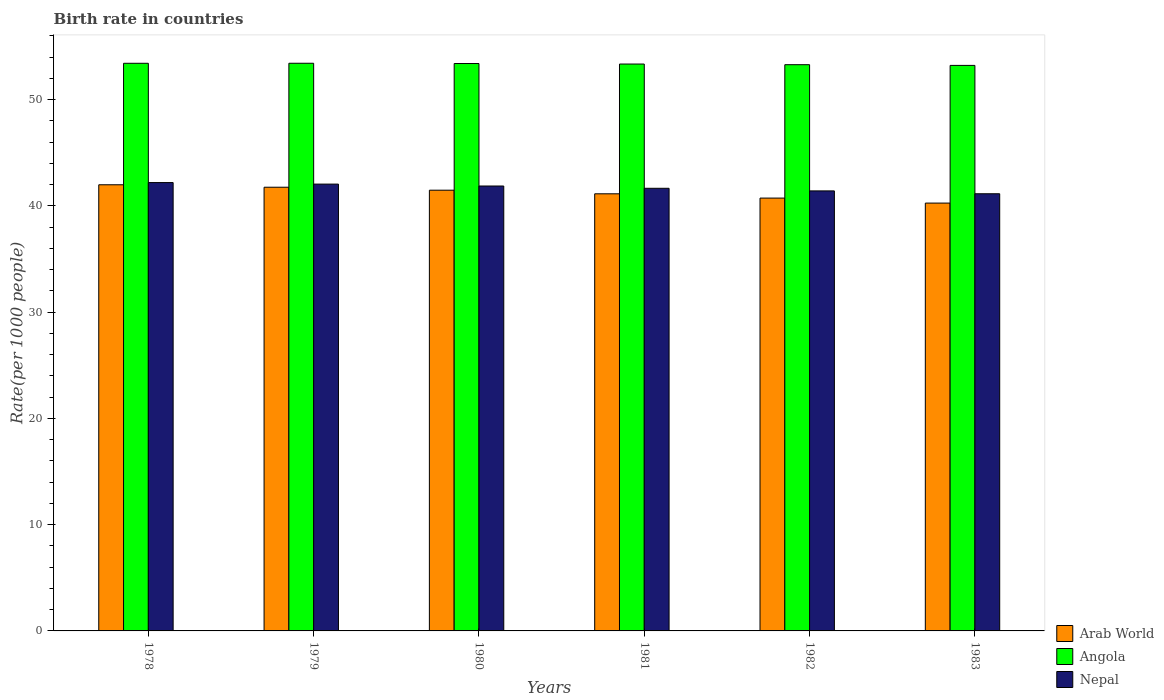Are the number of bars per tick equal to the number of legend labels?
Offer a terse response. Yes. Are the number of bars on each tick of the X-axis equal?
Your answer should be compact. Yes. How many bars are there on the 4th tick from the right?
Give a very brief answer. 3. What is the label of the 1st group of bars from the left?
Ensure brevity in your answer.  1978. In how many cases, is the number of bars for a given year not equal to the number of legend labels?
Make the answer very short. 0. What is the birth rate in Arab World in 1978?
Provide a succinct answer. 41.99. Across all years, what is the maximum birth rate in Nepal?
Give a very brief answer. 42.2. Across all years, what is the minimum birth rate in Nepal?
Provide a succinct answer. 41.14. In which year was the birth rate in Angola maximum?
Your response must be concise. 1979. In which year was the birth rate in Arab World minimum?
Provide a short and direct response. 1983. What is the total birth rate in Arab World in the graph?
Give a very brief answer. 247.36. What is the difference between the birth rate in Angola in 1979 and that in 1983?
Offer a terse response. 0.2. What is the difference between the birth rate in Angola in 1983 and the birth rate in Arab World in 1980?
Your answer should be compact. 11.75. What is the average birth rate in Arab World per year?
Offer a very short reply. 41.23. In the year 1978, what is the difference between the birth rate in Nepal and birth rate in Arab World?
Give a very brief answer. 0.21. What is the ratio of the birth rate in Angola in 1979 to that in 1983?
Your answer should be very brief. 1. Is the difference between the birth rate in Nepal in 1979 and 1981 greater than the difference between the birth rate in Arab World in 1979 and 1981?
Offer a terse response. No. What is the difference between the highest and the second highest birth rate in Arab World?
Your answer should be compact. 0.23. What is the difference between the highest and the lowest birth rate in Angola?
Provide a succinct answer. 0.2. Is the sum of the birth rate in Arab World in 1979 and 1983 greater than the maximum birth rate in Angola across all years?
Make the answer very short. Yes. What does the 1st bar from the left in 1980 represents?
Give a very brief answer. Arab World. What does the 1st bar from the right in 1983 represents?
Ensure brevity in your answer.  Nepal. Is it the case that in every year, the sum of the birth rate in Angola and birth rate in Nepal is greater than the birth rate in Arab World?
Make the answer very short. Yes. How many bars are there?
Make the answer very short. 18. How many years are there in the graph?
Offer a very short reply. 6. Are the values on the major ticks of Y-axis written in scientific E-notation?
Ensure brevity in your answer.  No. Does the graph contain any zero values?
Provide a short and direct response. No. Does the graph contain grids?
Your answer should be very brief. No. What is the title of the graph?
Your answer should be very brief. Birth rate in countries. What is the label or title of the Y-axis?
Give a very brief answer. Rate(per 1000 people). What is the Rate(per 1000 people) of Arab World in 1978?
Keep it short and to the point. 41.99. What is the Rate(per 1000 people) of Angola in 1978?
Offer a terse response. 53.42. What is the Rate(per 1000 people) in Nepal in 1978?
Your answer should be very brief. 42.2. What is the Rate(per 1000 people) of Arab World in 1979?
Your response must be concise. 41.76. What is the Rate(per 1000 people) in Angola in 1979?
Keep it short and to the point. 53.42. What is the Rate(per 1000 people) of Nepal in 1979?
Your response must be concise. 42.05. What is the Rate(per 1000 people) of Arab World in 1980?
Offer a very short reply. 41.48. What is the Rate(per 1000 people) in Angola in 1980?
Make the answer very short. 53.4. What is the Rate(per 1000 people) in Nepal in 1980?
Provide a succinct answer. 41.87. What is the Rate(per 1000 people) in Arab World in 1981?
Provide a short and direct response. 41.14. What is the Rate(per 1000 people) in Angola in 1981?
Provide a succinct answer. 53.35. What is the Rate(per 1000 people) in Nepal in 1981?
Your answer should be very brief. 41.66. What is the Rate(per 1000 people) of Arab World in 1982?
Your response must be concise. 40.73. What is the Rate(per 1000 people) in Angola in 1982?
Give a very brief answer. 53.29. What is the Rate(per 1000 people) in Nepal in 1982?
Keep it short and to the point. 41.41. What is the Rate(per 1000 people) in Arab World in 1983?
Your answer should be compact. 40.26. What is the Rate(per 1000 people) of Angola in 1983?
Keep it short and to the point. 53.22. What is the Rate(per 1000 people) in Nepal in 1983?
Provide a succinct answer. 41.14. Across all years, what is the maximum Rate(per 1000 people) of Arab World?
Your answer should be compact. 41.99. Across all years, what is the maximum Rate(per 1000 people) in Angola?
Your response must be concise. 53.42. Across all years, what is the maximum Rate(per 1000 people) of Nepal?
Make the answer very short. 42.2. Across all years, what is the minimum Rate(per 1000 people) in Arab World?
Your answer should be very brief. 40.26. Across all years, what is the minimum Rate(per 1000 people) in Angola?
Offer a terse response. 53.22. Across all years, what is the minimum Rate(per 1000 people) in Nepal?
Offer a very short reply. 41.14. What is the total Rate(per 1000 people) of Arab World in the graph?
Give a very brief answer. 247.36. What is the total Rate(per 1000 people) of Angola in the graph?
Offer a very short reply. 320.1. What is the total Rate(per 1000 people) in Nepal in the graph?
Ensure brevity in your answer.  250.33. What is the difference between the Rate(per 1000 people) of Arab World in 1978 and that in 1979?
Ensure brevity in your answer.  0.23. What is the difference between the Rate(per 1000 people) of Angola in 1978 and that in 1979?
Make the answer very short. -0. What is the difference between the Rate(per 1000 people) of Nepal in 1978 and that in 1979?
Make the answer very short. 0.14. What is the difference between the Rate(per 1000 people) of Arab World in 1978 and that in 1980?
Your answer should be compact. 0.51. What is the difference between the Rate(per 1000 people) in Angola in 1978 and that in 1980?
Make the answer very short. 0.02. What is the difference between the Rate(per 1000 people) in Nepal in 1978 and that in 1980?
Your response must be concise. 0.32. What is the difference between the Rate(per 1000 people) of Arab World in 1978 and that in 1981?
Provide a succinct answer. 0.85. What is the difference between the Rate(per 1000 people) of Angola in 1978 and that in 1981?
Your answer should be very brief. 0.07. What is the difference between the Rate(per 1000 people) in Nepal in 1978 and that in 1981?
Make the answer very short. 0.54. What is the difference between the Rate(per 1000 people) in Arab World in 1978 and that in 1982?
Your answer should be compact. 1.25. What is the difference between the Rate(per 1000 people) in Angola in 1978 and that in 1982?
Ensure brevity in your answer.  0.13. What is the difference between the Rate(per 1000 people) of Nepal in 1978 and that in 1982?
Provide a short and direct response. 0.78. What is the difference between the Rate(per 1000 people) of Arab World in 1978 and that in 1983?
Your answer should be compact. 1.72. What is the difference between the Rate(per 1000 people) in Angola in 1978 and that in 1983?
Offer a terse response. 0.2. What is the difference between the Rate(per 1000 people) of Nepal in 1978 and that in 1983?
Your answer should be very brief. 1.05. What is the difference between the Rate(per 1000 people) of Arab World in 1979 and that in 1980?
Provide a short and direct response. 0.28. What is the difference between the Rate(per 1000 people) of Angola in 1979 and that in 1980?
Provide a succinct answer. 0.03. What is the difference between the Rate(per 1000 people) in Nepal in 1979 and that in 1980?
Ensure brevity in your answer.  0.18. What is the difference between the Rate(per 1000 people) of Arab World in 1979 and that in 1981?
Provide a short and direct response. 0.62. What is the difference between the Rate(per 1000 people) of Angola in 1979 and that in 1981?
Your answer should be very brief. 0.07. What is the difference between the Rate(per 1000 people) in Nepal in 1979 and that in 1981?
Ensure brevity in your answer.  0.4. What is the difference between the Rate(per 1000 people) of Angola in 1979 and that in 1982?
Offer a terse response. 0.14. What is the difference between the Rate(per 1000 people) in Nepal in 1979 and that in 1982?
Give a very brief answer. 0.64. What is the difference between the Rate(per 1000 people) in Arab World in 1979 and that in 1983?
Offer a very short reply. 1.49. What is the difference between the Rate(per 1000 people) in Angola in 1979 and that in 1983?
Your answer should be very brief. 0.2. What is the difference between the Rate(per 1000 people) of Nepal in 1979 and that in 1983?
Your answer should be compact. 0.91. What is the difference between the Rate(per 1000 people) in Arab World in 1980 and that in 1981?
Ensure brevity in your answer.  0.34. What is the difference between the Rate(per 1000 people) of Angola in 1980 and that in 1981?
Your answer should be very brief. 0.05. What is the difference between the Rate(per 1000 people) in Nepal in 1980 and that in 1981?
Offer a terse response. 0.21. What is the difference between the Rate(per 1000 people) of Arab World in 1980 and that in 1982?
Your answer should be compact. 0.74. What is the difference between the Rate(per 1000 people) in Angola in 1980 and that in 1982?
Give a very brief answer. 0.11. What is the difference between the Rate(per 1000 people) in Nepal in 1980 and that in 1982?
Your response must be concise. 0.46. What is the difference between the Rate(per 1000 people) in Arab World in 1980 and that in 1983?
Your answer should be very brief. 1.21. What is the difference between the Rate(per 1000 people) in Angola in 1980 and that in 1983?
Provide a succinct answer. 0.18. What is the difference between the Rate(per 1000 people) of Nepal in 1980 and that in 1983?
Your answer should be very brief. 0.73. What is the difference between the Rate(per 1000 people) in Arab World in 1981 and that in 1982?
Offer a very short reply. 0.4. What is the difference between the Rate(per 1000 people) in Angola in 1981 and that in 1982?
Ensure brevity in your answer.  0.06. What is the difference between the Rate(per 1000 people) in Nepal in 1981 and that in 1982?
Your answer should be very brief. 0.24. What is the difference between the Rate(per 1000 people) of Arab World in 1981 and that in 1983?
Your response must be concise. 0.87. What is the difference between the Rate(per 1000 people) of Angola in 1981 and that in 1983?
Give a very brief answer. 0.13. What is the difference between the Rate(per 1000 people) of Nepal in 1981 and that in 1983?
Your answer should be very brief. 0.51. What is the difference between the Rate(per 1000 people) in Arab World in 1982 and that in 1983?
Keep it short and to the point. 0.47. What is the difference between the Rate(per 1000 people) of Angola in 1982 and that in 1983?
Offer a terse response. 0.07. What is the difference between the Rate(per 1000 people) of Nepal in 1982 and that in 1983?
Provide a succinct answer. 0.27. What is the difference between the Rate(per 1000 people) in Arab World in 1978 and the Rate(per 1000 people) in Angola in 1979?
Provide a short and direct response. -11.44. What is the difference between the Rate(per 1000 people) of Arab World in 1978 and the Rate(per 1000 people) of Nepal in 1979?
Make the answer very short. -0.06. What is the difference between the Rate(per 1000 people) in Angola in 1978 and the Rate(per 1000 people) in Nepal in 1979?
Give a very brief answer. 11.37. What is the difference between the Rate(per 1000 people) of Arab World in 1978 and the Rate(per 1000 people) of Angola in 1980?
Offer a very short reply. -11.41. What is the difference between the Rate(per 1000 people) of Arab World in 1978 and the Rate(per 1000 people) of Nepal in 1980?
Provide a short and direct response. 0.12. What is the difference between the Rate(per 1000 people) of Angola in 1978 and the Rate(per 1000 people) of Nepal in 1980?
Give a very brief answer. 11.55. What is the difference between the Rate(per 1000 people) in Arab World in 1978 and the Rate(per 1000 people) in Angola in 1981?
Ensure brevity in your answer.  -11.36. What is the difference between the Rate(per 1000 people) of Arab World in 1978 and the Rate(per 1000 people) of Nepal in 1981?
Your answer should be very brief. 0.33. What is the difference between the Rate(per 1000 people) of Angola in 1978 and the Rate(per 1000 people) of Nepal in 1981?
Your answer should be very brief. 11.76. What is the difference between the Rate(per 1000 people) of Arab World in 1978 and the Rate(per 1000 people) of Angola in 1982?
Provide a succinct answer. -11.3. What is the difference between the Rate(per 1000 people) of Arab World in 1978 and the Rate(per 1000 people) of Nepal in 1982?
Make the answer very short. 0.58. What is the difference between the Rate(per 1000 people) of Angola in 1978 and the Rate(per 1000 people) of Nepal in 1982?
Offer a very short reply. 12.01. What is the difference between the Rate(per 1000 people) in Arab World in 1978 and the Rate(per 1000 people) in Angola in 1983?
Your answer should be very brief. -11.23. What is the difference between the Rate(per 1000 people) in Arab World in 1978 and the Rate(per 1000 people) in Nepal in 1983?
Ensure brevity in your answer.  0.85. What is the difference between the Rate(per 1000 people) of Angola in 1978 and the Rate(per 1000 people) of Nepal in 1983?
Keep it short and to the point. 12.28. What is the difference between the Rate(per 1000 people) in Arab World in 1979 and the Rate(per 1000 people) in Angola in 1980?
Make the answer very short. -11.64. What is the difference between the Rate(per 1000 people) of Arab World in 1979 and the Rate(per 1000 people) of Nepal in 1980?
Your response must be concise. -0.11. What is the difference between the Rate(per 1000 people) of Angola in 1979 and the Rate(per 1000 people) of Nepal in 1980?
Offer a very short reply. 11.55. What is the difference between the Rate(per 1000 people) in Arab World in 1979 and the Rate(per 1000 people) in Angola in 1981?
Offer a very short reply. -11.59. What is the difference between the Rate(per 1000 people) in Arab World in 1979 and the Rate(per 1000 people) in Nepal in 1981?
Make the answer very short. 0.1. What is the difference between the Rate(per 1000 people) in Angola in 1979 and the Rate(per 1000 people) in Nepal in 1981?
Keep it short and to the point. 11.77. What is the difference between the Rate(per 1000 people) in Arab World in 1979 and the Rate(per 1000 people) in Angola in 1982?
Your answer should be compact. -11.53. What is the difference between the Rate(per 1000 people) of Arab World in 1979 and the Rate(per 1000 people) of Nepal in 1982?
Make the answer very short. 0.35. What is the difference between the Rate(per 1000 people) in Angola in 1979 and the Rate(per 1000 people) in Nepal in 1982?
Your response must be concise. 12.01. What is the difference between the Rate(per 1000 people) in Arab World in 1979 and the Rate(per 1000 people) in Angola in 1983?
Make the answer very short. -11.47. What is the difference between the Rate(per 1000 people) in Arab World in 1979 and the Rate(per 1000 people) in Nepal in 1983?
Provide a short and direct response. 0.61. What is the difference between the Rate(per 1000 people) in Angola in 1979 and the Rate(per 1000 people) in Nepal in 1983?
Your answer should be compact. 12.28. What is the difference between the Rate(per 1000 people) in Arab World in 1980 and the Rate(per 1000 people) in Angola in 1981?
Provide a short and direct response. -11.87. What is the difference between the Rate(per 1000 people) of Arab World in 1980 and the Rate(per 1000 people) of Nepal in 1981?
Offer a very short reply. -0.18. What is the difference between the Rate(per 1000 people) in Angola in 1980 and the Rate(per 1000 people) in Nepal in 1981?
Give a very brief answer. 11.74. What is the difference between the Rate(per 1000 people) in Arab World in 1980 and the Rate(per 1000 people) in Angola in 1982?
Offer a very short reply. -11.81. What is the difference between the Rate(per 1000 people) of Arab World in 1980 and the Rate(per 1000 people) of Nepal in 1982?
Your response must be concise. 0.07. What is the difference between the Rate(per 1000 people) of Angola in 1980 and the Rate(per 1000 people) of Nepal in 1982?
Ensure brevity in your answer.  11.99. What is the difference between the Rate(per 1000 people) of Arab World in 1980 and the Rate(per 1000 people) of Angola in 1983?
Give a very brief answer. -11.75. What is the difference between the Rate(per 1000 people) of Arab World in 1980 and the Rate(per 1000 people) of Nepal in 1983?
Ensure brevity in your answer.  0.33. What is the difference between the Rate(per 1000 people) of Angola in 1980 and the Rate(per 1000 people) of Nepal in 1983?
Your answer should be compact. 12.26. What is the difference between the Rate(per 1000 people) of Arab World in 1981 and the Rate(per 1000 people) of Angola in 1982?
Offer a terse response. -12.15. What is the difference between the Rate(per 1000 people) in Arab World in 1981 and the Rate(per 1000 people) in Nepal in 1982?
Ensure brevity in your answer.  -0.27. What is the difference between the Rate(per 1000 people) of Angola in 1981 and the Rate(per 1000 people) of Nepal in 1982?
Offer a terse response. 11.94. What is the difference between the Rate(per 1000 people) in Arab World in 1981 and the Rate(per 1000 people) in Angola in 1983?
Offer a very short reply. -12.08. What is the difference between the Rate(per 1000 people) of Arab World in 1981 and the Rate(per 1000 people) of Nepal in 1983?
Make the answer very short. -0. What is the difference between the Rate(per 1000 people) in Angola in 1981 and the Rate(per 1000 people) in Nepal in 1983?
Provide a succinct answer. 12.21. What is the difference between the Rate(per 1000 people) in Arab World in 1982 and the Rate(per 1000 people) in Angola in 1983?
Offer a terse response. -12.49. What is the difference between the Rate(per 1000 people) of Arab World in 1982 and the Rate(per 1000 people) of Nepal in 1983?
Provide a short and direct response. -0.41. What is the difference between the Rate(per 1000 people) of Angola in 1982 and the Rate(per 1000 people) of Nepal in 1983?
Give a very brief answer. 12.15. What is the average Rate(per 1000 people) of Arab World per year?
Make the answer very short. 41.23. What is the average Rate(per 1000 people) of Angola per year?
Keep it short and to the point. 53.35. What is the average Rate(per 1000 people) in Nepal per year?
Offer a very short reply. 41.72. In the year 1978, what is the difference between the Rate(per 1000 people) of Arab World and Rate(per 1000 people) of Angola?
Offer a terse response. -11.43. In the year 1978, what is the difference between the Rate(per 1000 people) in Arab World and Rate(per 1000 people) in Nepal?
Your answer should be very brief. -0.21. In the year 1978, what is the difference between the Rate(per 1000 people) of Angola and Rate(per 1000 people) of Nepal?
Keep it short and to the point. 11.22. In the year 1979, what is the difference between the Rate(per 1000 people) in Arab World and Rate(per 1000 people) in Angola?
Ensure brevity in your answer.  -11.67. In the year 1979, what is the difference between the Rate(per 1000 people) in Arab World and Rate(per 1000 people) in Nepal?
Provide a short and direct response. -0.29. In the year 1979, what is the difference between the Rate(per 1000 people) in Angola and Rate(per 1000 people) in Nepal?
Give a very brief answer. 11.37. In the year 1980, what is the difference between the Rate(per 1000 people) in Arab World and Rate(per 1000 people) in Angola?
Your answer should be very brief. -11.92. In the year 1980, what is the difference between the Rate(per 1000 people) in Arab World and Rate(per 1000 people) in Nepal?
Offer a very short reply. -0.39. In the year 1980, what is the difference between the Rate(per 1000 people) in Angola and Rate(per 1000 people) in Nepal?
Give a very brief answer. 11.53. In the year 1981, what is the difference between the Rate(per 1000 people) of Arab World and Rate(per 1000 people) of Angola?
Make the answer very short. -12.21. In the year 1981, what is the difference between the Rate(per 1000 people) in Arab World and Rate(per 1000 people) in Nepal?
Your response must be concise. -0.52. In the year 1981, what is the difference between the Rate(per 1000 people) of Angola and Rate(per 1000 people) of Nepal?
Ensure brevity in your answer.  11.69. In the year 1982, what is the difference between the Rate(per 1000 people) in Arab World and Rate(per 1000 people) in Angola?
Provide a succinct answer. -12.55. In the year 1982, what is the difference between the Rate(per 1000 people) of Arab World and Rate(per 1000 people) of Nepal?
Offer a terse response. -0.68. In the year 1982, what is the difference between the Rate(per 1000 people) of Angola and Rate(per 1000 people) of Nepal?
Keep it short and to the point. 11.88. In the year 1983, what is the difference between the Rate(per 1000 people) in Arab World and Rate(per 1000 people) in Angola?
Your answer should be compact. -12.96. In the year 1983, what is the difference between the Rate(per 1000 people) of Arab World and Rate(per 1000 people) of Nepal?
Your response must be concise. -0.88. In the year 1983, what is the difference between the Rate(per 1000 people) in Angola and Rate(per 1000 people) in Nepal?
Make the answer very short. 12.08. What is the ratio of the Rate(per 1000 people) in Arab World in 1978 to that in 1979?
Your answer should be compact. 1.01. What is the ratio of the Rate(per 1000 people) of Nepal in 1978 to that in 1979?
Provide a short and direct response. 1. What is the ratio of the Rate(per 1000 people) of Arab World in 1978 to that in 1980?
Offer a terse response. 1.01. What is the ratio of the Rate(per 1000 people) in Nepal in 1978 to that in 1980?
Offer a very short reply. 1.01. What is the ratio of the Rate(per 1000 people) in Arab World in 1978 to that in 1981?
Offer a terse response. 1.02. What is the ratio of the Rate(per 1000 people) of Nepal in 1978 to that in 1981?
Offer a terse response. 1.01. What is the ratio of the Rate(per 1000 people) in Arab World in 1978 to that in 1982?
Provide a succinct answer. 1.03. What is the ratio of the Rate(per 1000 people) in Angola in 1978 to that in 1982?
Your response must be concise. 1. What is the ratio of the Rate(per 1000 people) of Nepal in 1978 to that in 1982?
Make the answer very short. 1.02. What is the ratio of the Rate(per 1000 people) in Arab World in 1978 to that in 1983?
Ensure brevity in your answer.  1.04. What is the ratio of the Rate(per 1000 people) in Nepal in 1978 to that in 1983?
Give a very brief answer. 1.03. What is the ratio of the Rate(per 1000 people) in Arab World in 1979 to that in 1980?
Offer a very short reply. 1.01. What is the ratio of the Rate(per 1000 people) in Angola in 1979 to that in 1980?
Your answer should be compact. 1. What is the ratio of the Rate(per 1000 people) of Arab World in 1979 to that in 1981?
Provide a succinct answer. 1.01. What is the ratio of the Rate(per 1000 people) in Nepal in 1979 to that in 1981?
Give a very brief answer. 1.01. What is the ratio of the Rate(per 1000 people) of Arab World in 1979 to that in 1982?
Give a very brief answer. 1.03. What is the ratio of the Rate(per 1000 people) in Angola in 1979 to that in 1982?
Your answer should be very brief. 1. What is the ratio of the Rate(per 1000 people) of Nepal in 1979 to that in 1982?
Ensure brevity in your answer.  1.02. What is the ratio of the Rate(per 1000 people) in Arab World in 1979 to that in 1983?
Your answer should be very brief. 1.04. What is the ratio of the Rate(per 1000 people) in Nepal in 1979 to that in 1983?
Your answer should be very brief. 1.02. What is the ratio of the Rate(per 1000 people) of Arab World in 1980 to that in 1981?
Keep it short and to the point. 1.01. What is the ratio of the Rate(per 1000 people) of Angola in 1980 to that in 1981?
Your response must be concise. 1. What is the ratio of the Rate(per 1000 people) of Arab World in 1980 to that in 1982?
Your answer should be very brief. 1.02. What is the ratio of the Rate(per 1000 people) in Nepal in 1980 to that in 1982?
Offer a very short reply. 1.01. What is the ratio of the Rate(per 1000 people) in Arab World in 1980 to that in 1983?
Provide a succinct answer. 1.03. What is the ratio of the Rate(per 1000 people) in Nepal in 1980 to that in 1983?
Offer a very short reply. 1.02. What is the ratio of the Rate(per 1000 people) of Arab World in 1981 to that in 1982?
Ensure brevity in your answer.  1.01. What is the ratio of the Rate(per 1000 people) in Nepal in 1981 to that in 1982?
Your answer should be compact. 1.01. What is the ratio of the Rate(per 1000 people) in Arab World in 1981 to that in 1983?
Keep it short and to the point. 1.02. What is the ratio of the Rate(per 1000 people) in Nepal in 1981 to that in 1983?
Provide a succinct answer. 1.01. What is the ratio of the Rate(per 1000 people) of Arab World in 1982 to that in 1983?
Offer a terse response. 1.01. What is the ratio of the Rate(per 1000 people) of Nepal in 1982 to that in 1983?
Make the answer very short. 1.01. What is the difference between the highest and the second highest Rate(per 1000 people) in Arab World?
Offer a very short reply. 0.23. What is the difference between the highest and the second highest Rate(per 1000 people) in Angola?
Provide a short and direct response. 0. What is the difference between the highest and the second highest Rate(per 1000 people) of Nepal?
Make the answer very short. 0.14. What is the difference between the highest and the lowest Rate(per 1000 people) in Arab World?
Provide a succinct answer. 1.72. What is the difference between the highest and the lowest Rate(per 1000 people) of Angola?
Your answer should be compact. 0.2. What is the difference between the highest and the lowest Rate(per 1000 people) of Nepal?
Provide a succinct answer. 1.05. 